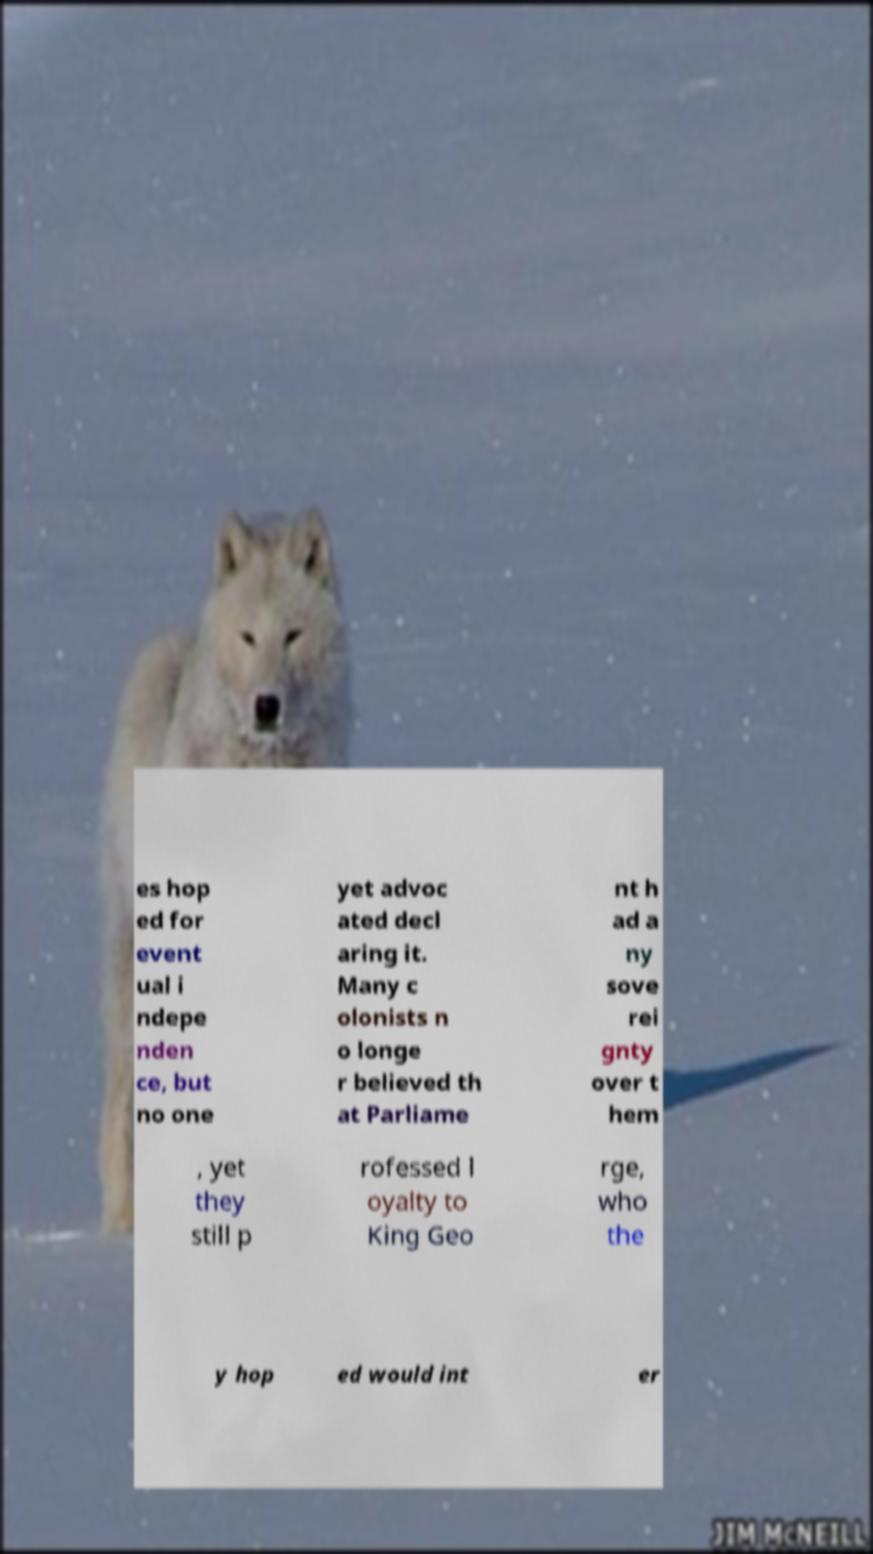I need the written content from this picture converted into text. Can you do that? es hop ed for event ual i ndepe nden ce, but no one yet advoc ated decl aring it. Many c olonists n o longe r believed th at Parliame nt h ad a ny sove rei gnty over t hem , yet they still p rofessed l oyalty to King Geo rge, who the y hop ed would int er 